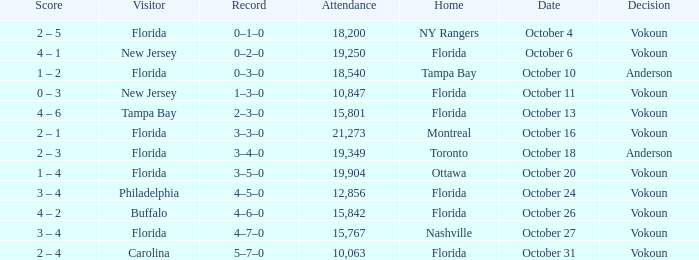What was the score on October 13? 4 – 6. 